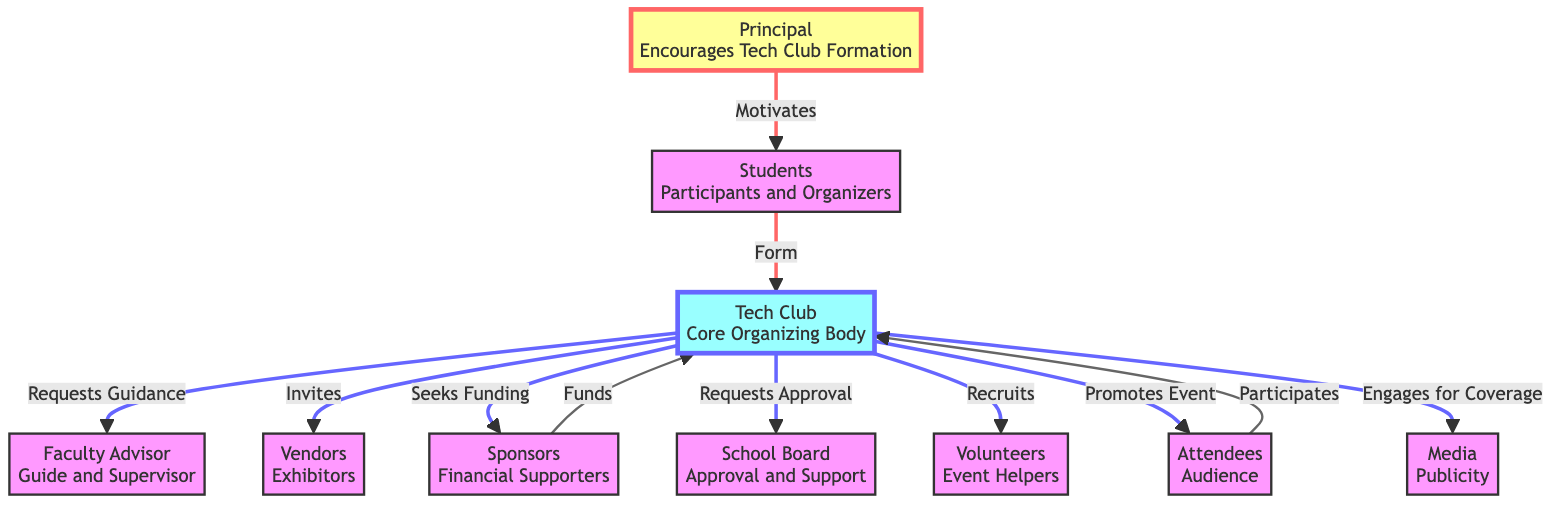What is the role of the Principal in the diagram? The Principal is labeled as "Encourages Tech Club Formation" and is identified as motivating students to participate in the Tech Fair planning.
Answer: Encourages Tech Club Formation How many nodes are in the diagram? Counting the distinct entities listed under "nodes" in the data, there are ten nodes in total: Principal, Students, Tech Club, Faculty Advisor, Vendors, Sponsors, School Board, Volunteers, Attendees, and Media.
Answer: 10 Who do the students form a connection with? According to the edges, the students form a connection with the Tech Club indicated by the label "Form," meaning they are responsible for establishing the club.
Answer: Tech Club What action does the Tech Club take towards the school board? The Tech Club requests approval from the school board, as shown in the edge labeled "Requests Approval" connecting these two nodes.
Answer: Requests Approval How many edges are represented in the diagram? By counting the relationships specified in the "edges" section, there are eleven edges in total illustrating the interactions among the nodes.
Answer: 11 Which node shows financial support for the Tech Club? The Sponsors provide financial support as indicated by the edge labeled "Funds," connecting the Sponsors node to the Tech Club node.
Answer: Sponsors What type of role do the volunteers play in the event? Volunteers are described as "Event Helpers," indicating that their primary role is to assist in various tasks during the tech fair event.
Answer: Event Helpers How does the Tech Club engage with the media? The Tech Club engages with the media for coverage as shown by the edge labeled "Engages for Coverage" connecting these two entities.
Answer: Engages for Coverage Which group is responsible for promoting the event? The Tech Club promotes the event, as indicated by the edge labeled "Promotes Event" that connects the Tech Club node to the Attendees node.
Answer: Tech Club 